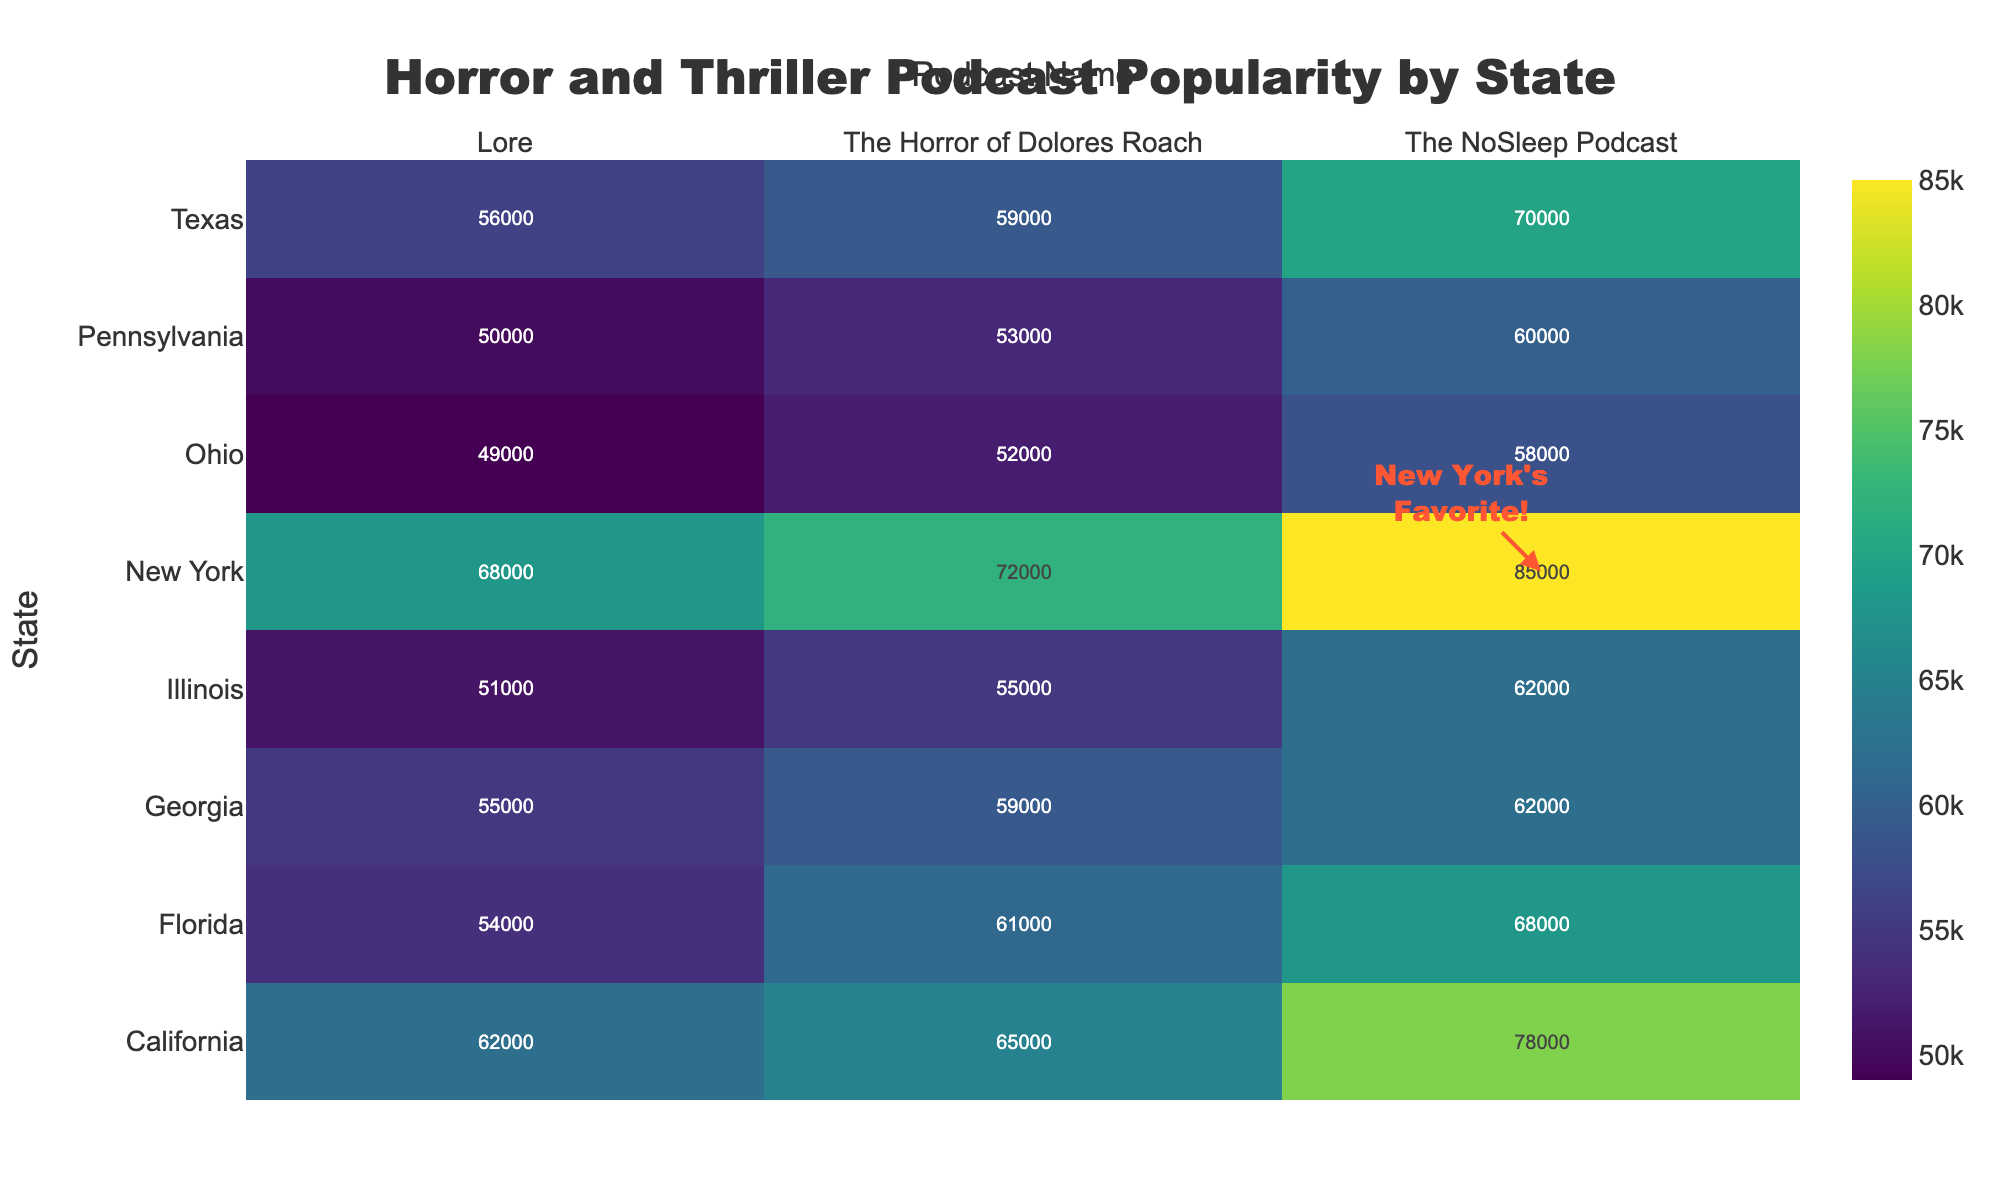What's the title of the heatmap? The title is typically found at the top center of the figure, it helps to understand the main topic of the plot.
Answer: Horror and Thriller Podcast Popularity by State Which state has the highest number of average monthly listeners for "The NoSleep Podcast"? Look for the cell corresponding to "The NoSleep Podcast" in the New York row and compare it to the other states. New York shows the highest value.
Answer: New York How many listeners does "The Horror of Dolores Roach" have in California? Identify the intersecting cell for California and "The Horror of Dolores Roach," which shows the exact number of listeners for this podcast in California.
Answer: 65,000 What is the difference in average monthly listeners for "The NoSleep Podcast" between New York and Texas? Find the values for New York and Texas in "The NoSleep Podcast" column, and compute the difference (85,000 - 70,000).
Answer: 15,000 Which podcast has the fewest average monthly listeners in Illinois? Compare the values for each podcast in the Illinois row and identify the lowest one.
Answer: Lore How does New York's listener count for "Lore" compare to Georgia's? Compare the values in the Lore column for New York and Georgia. New York has 68,000, and Georgia has 55,000.
Answer: New York has more listeners Which state has the most even distribution of listeners across all three podcasts? Compare the listener numbers for each podcast within each state, looking for the state with the numbers closest to each other.
Answer: Georgia What annotation is highlighted for New York and what’s its significance? The annotation highlights "New York's Favorite!" pointing out that "The NoSleep Podcast" is most popular in New York compared to other states. This highlights New York's top listening trend.
Answer: New York's Favorite! What’s the overall trend in podcast popularity in New York compared to other states? Observe the heatmap for New York comparing listener numbers across the three mentioned podcasts. New York consistently has the highest or high numbers across all podcasts.
Answer: Higher popularity What is the combined total of average monthly listeners for "Lore" across all states? Sum all the values in the "Lore" column (68,000 + 62,000 + 56,000 + 54,000 + 51,000 + 50,000 + 49,000 + 55,000). Calculate the combined total.
Answer: 445,000 